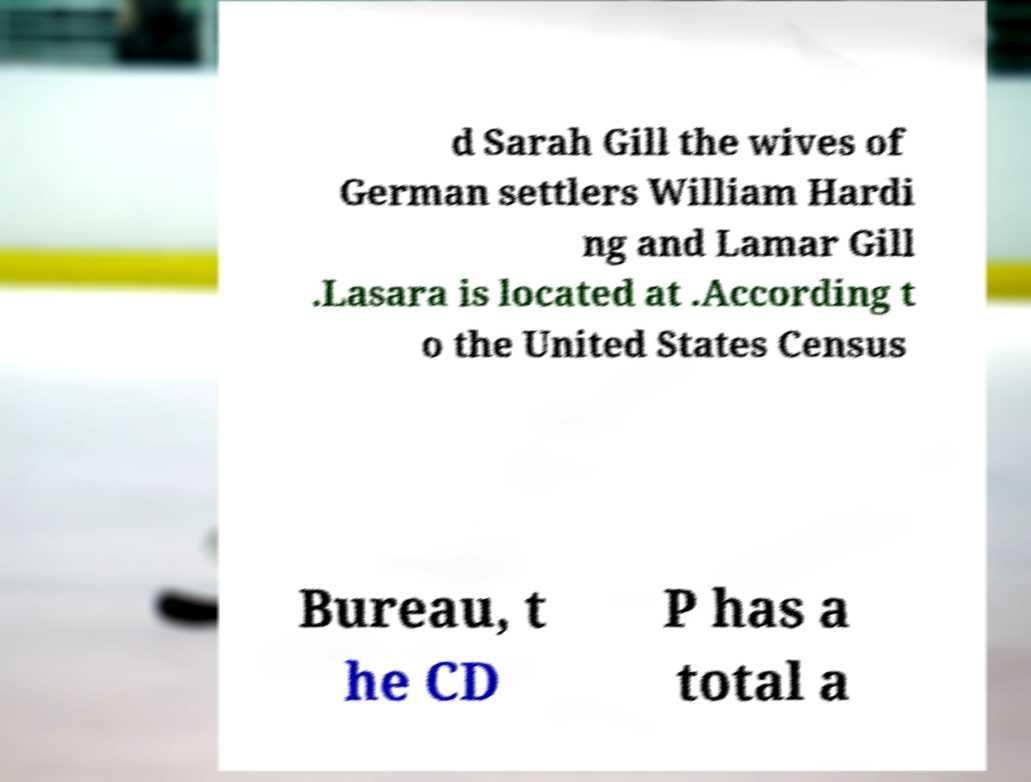Can you accurately transcribe the text from the provided image for me? d Sarah Gill the wives of German settlers William Hardi ng and Lamar Gill .Lasara is located at .According t o the United States Census Bureau, t he CD P has a total a 